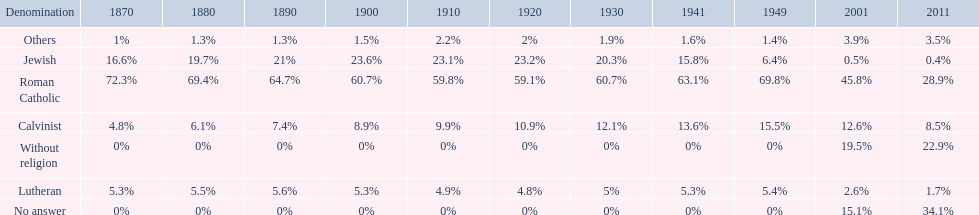How many denominations never dropped below 20%? 1. 